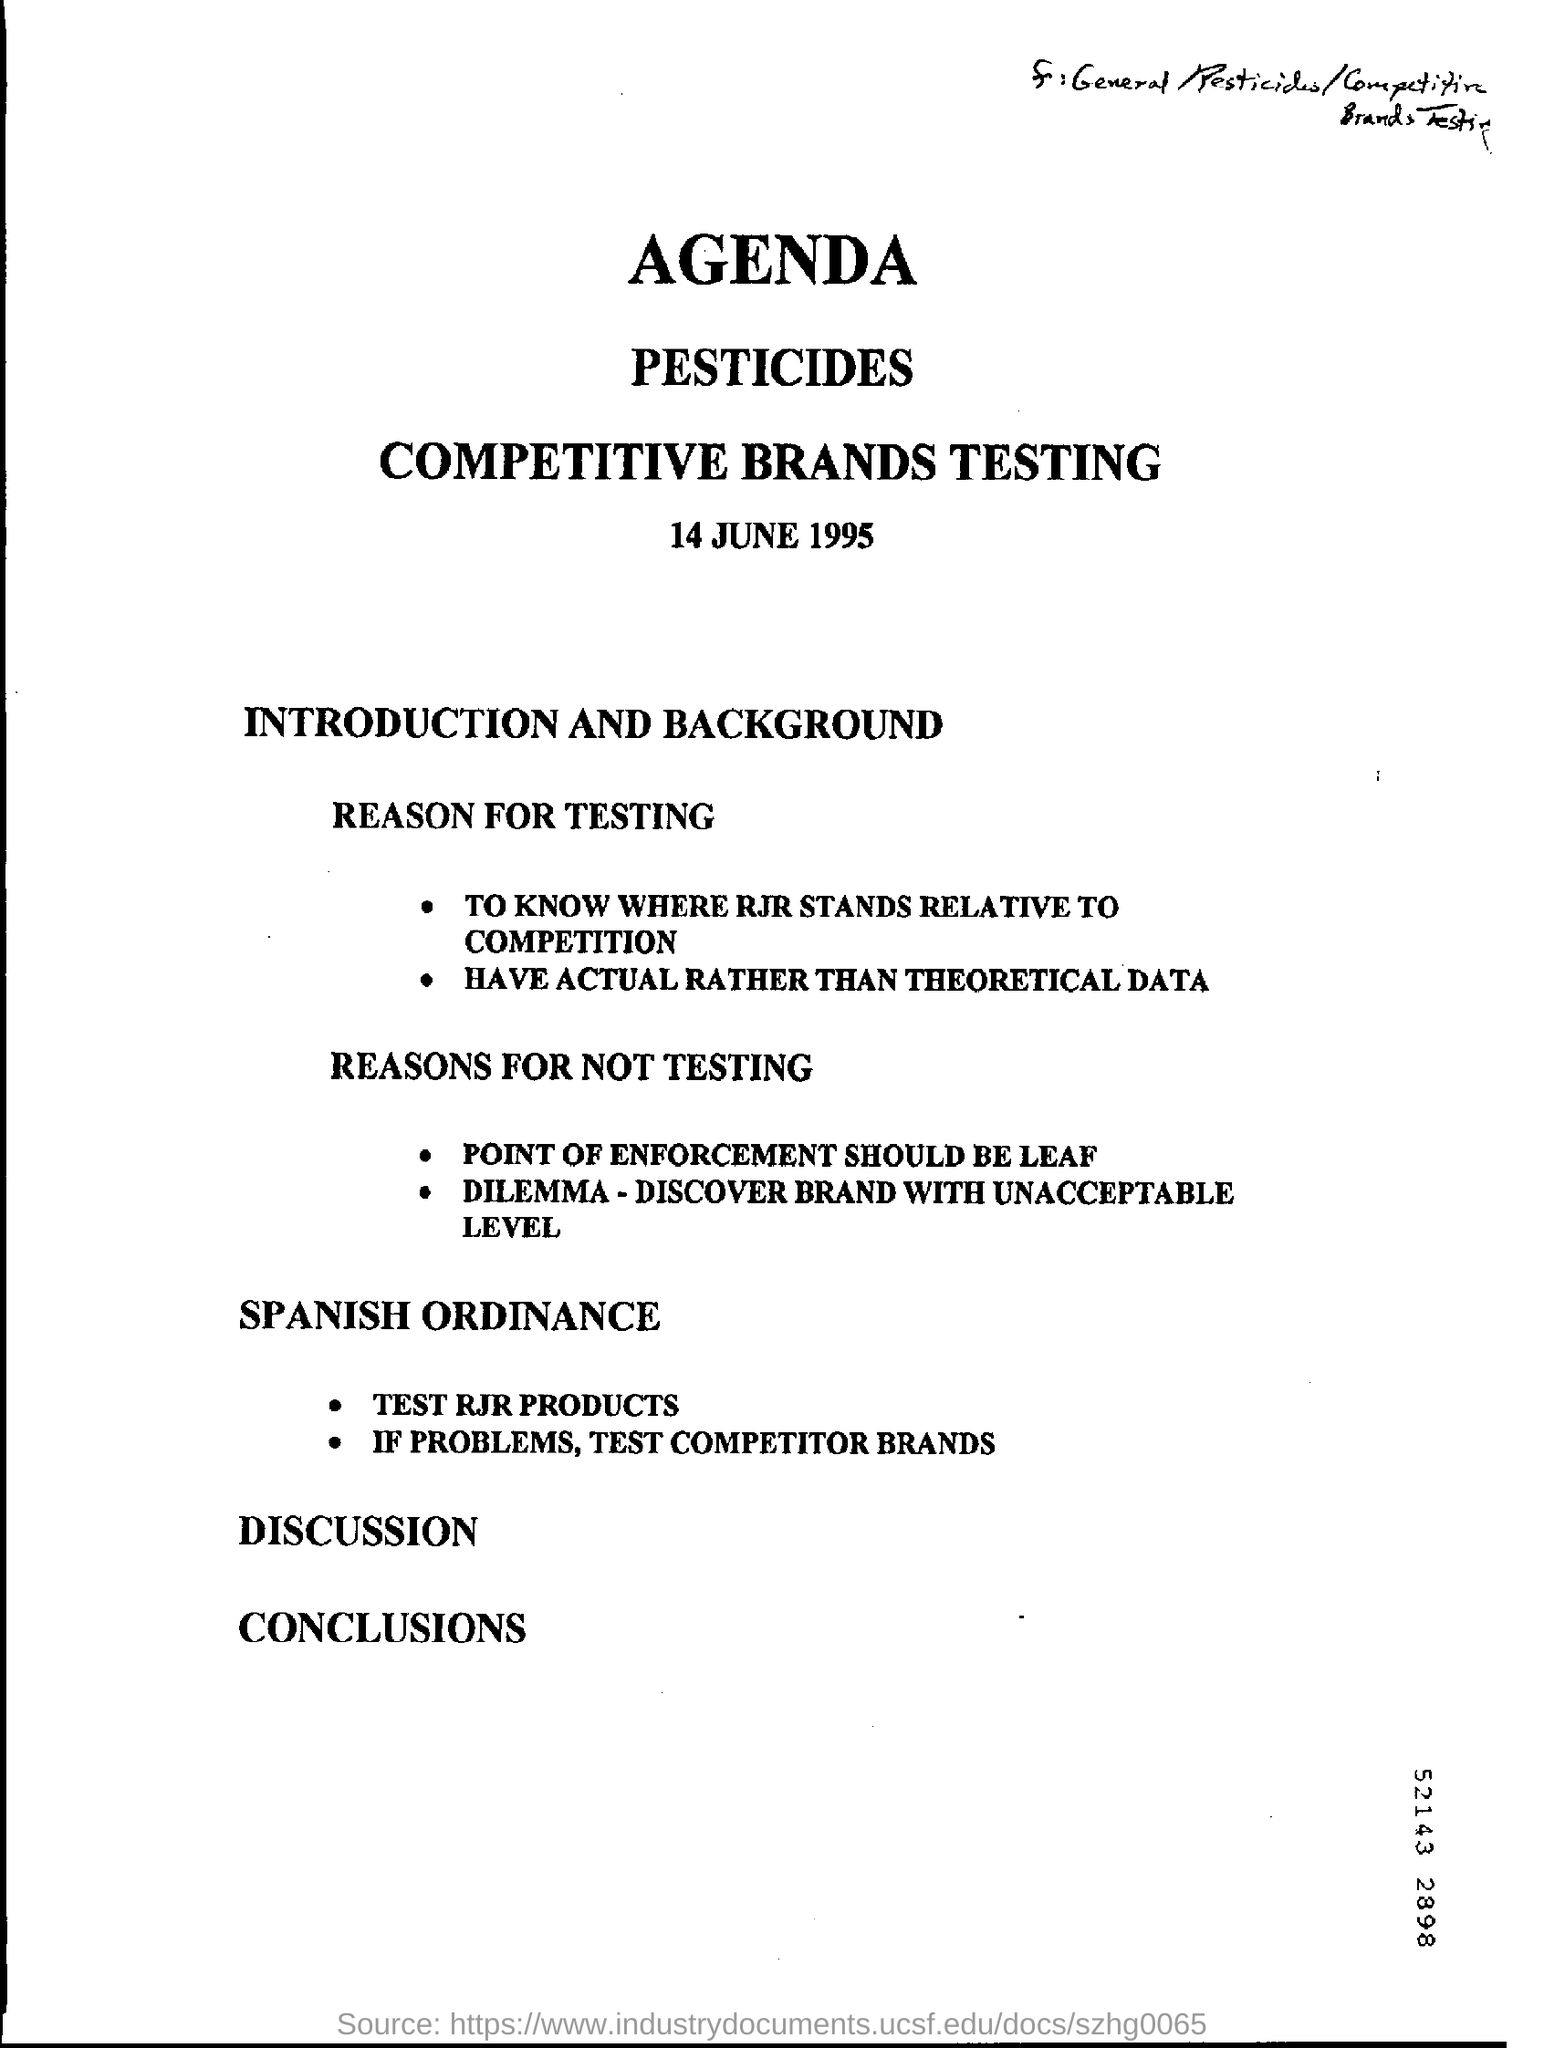Mention a couple of crucial points in this snapshot. The date mentioned in this document is June 14, 1995. 